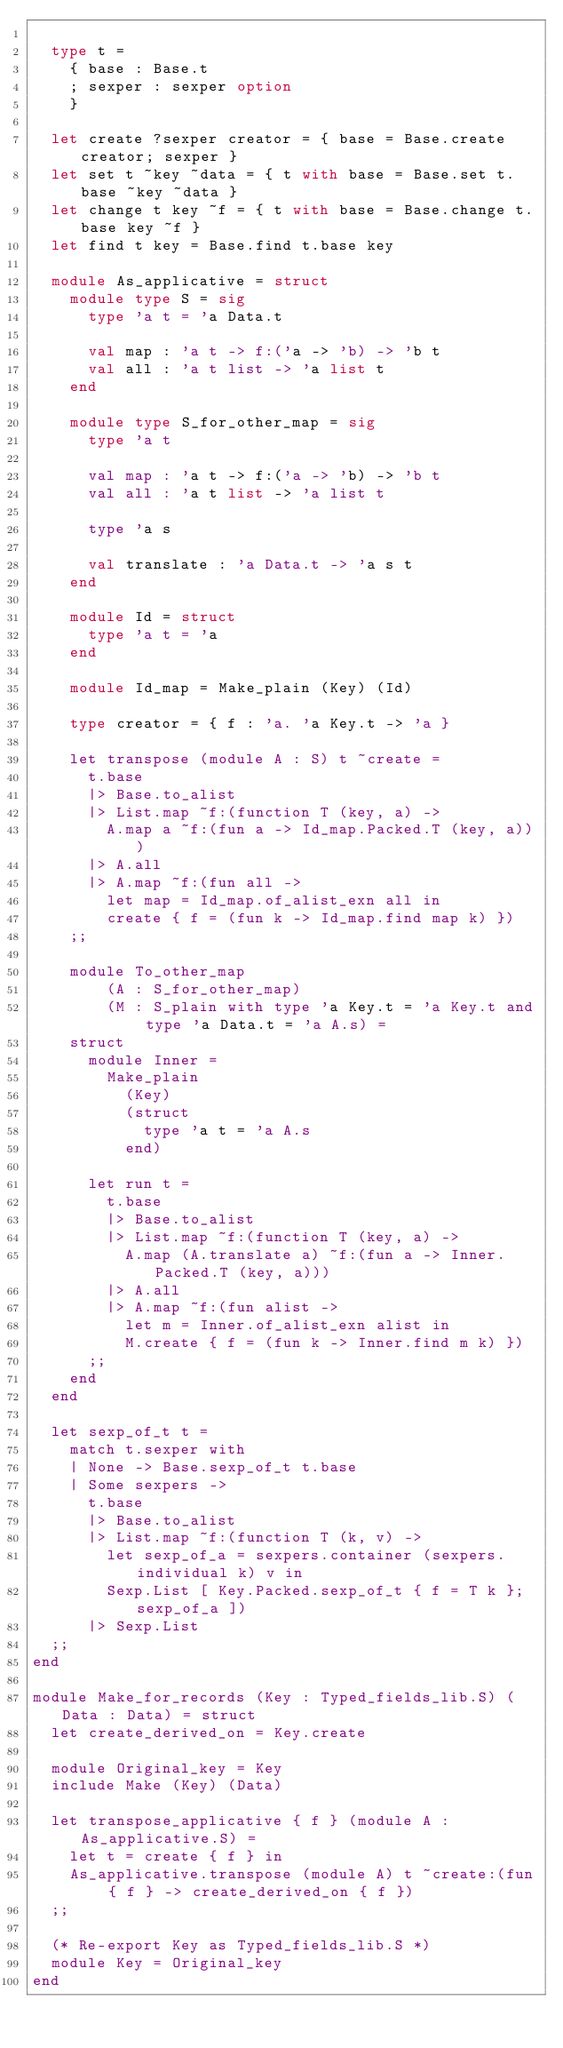Convert code to text. <code><loc_0><loc_0><loc_500><loc_500><_OCaml_>
  type t =
    { base : Base.t
    ; sexper : sexper option
    }

  let create ?sexper creator = { base = Base.create creator; sexper }
  let set t ~key ~data = { t with base = Base.set t.base ~key ~data }
  let change t key ~f = { t with base = Base.change t.base key ~f }
  let find t key = Base.find t.base key

  module As_applicative = struct
    module type S = sig
      type 'a t = 'a Data.t

      val map : 'a t -> f:('a -> 'b) -> 'b t
      val all : 'a t list -> 'a list t
    end

    module type S_for_other_map = sig
      type 'a t

      val map : 'a t -> f:('a -> 'b) -> 'b t
      val all : 'a t list -> 'a list t

      type 'a s

      val translate : 'a Data.t -> 'a s t
    end

    module Id = struct
      type 'a t = 'a
    end

    module Id_map = Make_plain (Key) (Id)

    type creator = { f : 'a. 'a Key.t -> 'a }

    let transpose (module A : S) t ~create =
      t.base
      |> Base.to_alist
      |> List.map ~f:(function T (key, a) ->
        A.map a ~f:(fun a -> Id_map.Packed.T (key, a)))
      |> A.all
      |> A.map ~f:(fun all ->
        let map = Id_map.of_alist_exn all in
        create { f = (fun k -> Id_map.find map k) })
    ;;

    module To_other_map
        (A : S_for_other_map)
        (M : S_plain with type 'a Key.t = 'a Key.t and type 'a Data.t = 'a A.s) =
    struct
      module Inner =
        Make_plain
          (Key)
          (struct
            type 'a t = 'a A.s
          end)

      let run t =
        t.base
        |> Base.to_alist
        |> List.map ~f:(function T (key, a) ->
          A.map (A.translate a) ~f:(fun a -> Inner.Packed.T (key, a)))
        |> A.all
        |> A.map ~f:(fun alist ->
          let m = Inner.of_alist_exn alist in
          M.create { f = (fun k -> Inner.find m k) })
      ;;
    end
  end

  let sexp_of_t t =
    match t.sexper with
    | None -> Base.sexp_of_t t.base
    | Some sexpers ->
      t.base
      |> Base.to_alist
      |> List.map ~f:(function T (k, v) ->
        let sexp_of_a = sexpers.container (sexpers.individual k) v in
        Sexp.List [ Key.Packed.sexp_of_t { f = T k }; sexp_of_a ])
      |> Sexp.List
  ;;
end

module Make_for_records (Key : Typed_fields_lib.S) (Data : Data) = struct
  let create_derived_on = Key.create

  module Original_key = Key
  include Make (Key) (Data)

  let transpose_applicative { f } (module A : As_applicative.S) =
    let t = create { f } in
    As_applicative.transpose (module A) t ~create:(fun { f } -> create_derived_on { f })
  ;;

  (* Re-export Key as Typed_fields_lib.S *)
  module Key = Original_key
end
</code> 